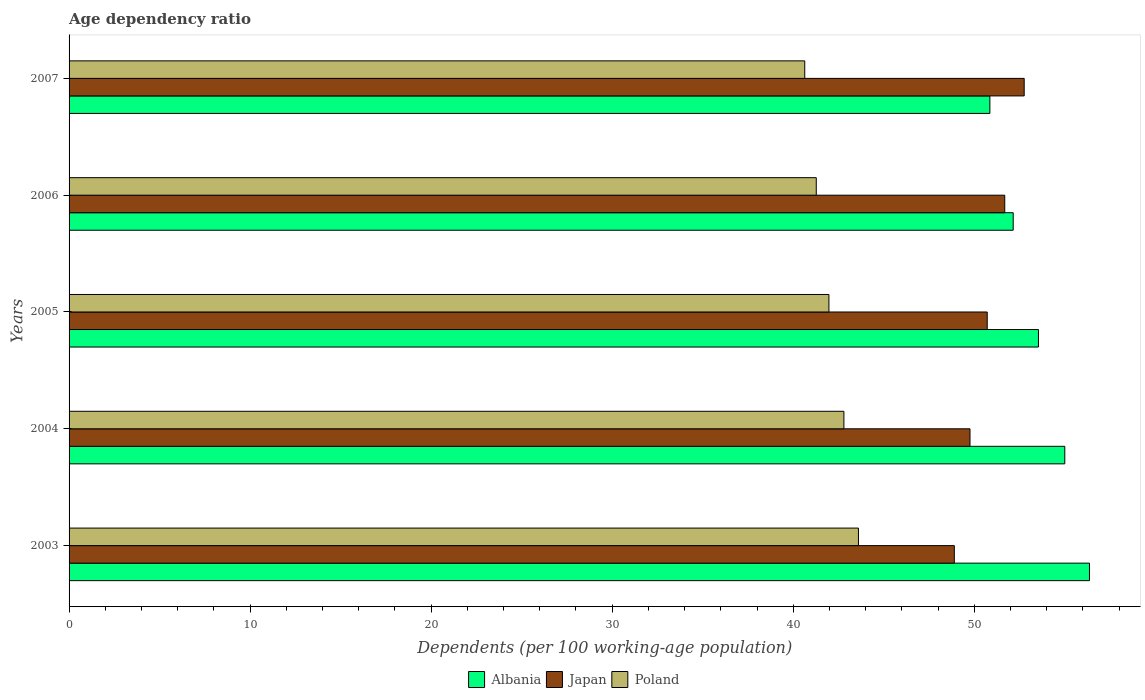How many bars are there on the 2nd tick from the top?
Make the answer very short. 3. How many bars are there on the 2nd tick from the bottom?
Offer a very short reply. 3. In how many cases, is the number of bars for a given year not equal to the number of legend labels?
Provide a succinct answer. 0. What is the age dependency ratio in in Poland in 2004?
Provide a succinct answer. 42.8. Across all years, what is the maximum age dependency ratio in in Albania?
Ensure brevity in your answer.  56.36. Across all years, what is the minimum age dependency ratio in in Japan?
Ensure brevity in your answer.  48.9. In which year was the age dependency ratio in in Japan maximum?
Keep it short and to the point. 2007. What is the total age dependency ratio in in Albania in the graph?
Provide a short and direct response. 267.93. What is the difference between the age dependency ratio in in Albania in 2003 and that in 2006?
Your answer should be very brief. 4.21. What is the difference between the age dependency ratio in in Japan in 2007 and the age dependency ratio in in Albania in 2003?
Keep it short and to the point. -3.61. What is the average age dependency ratio in in Albania per year?
Your response must be concise. 53.59. In the year 2006, what is the difference between the age dependency ratio in in Albania and age dependency ratio in in Poland?
Ensure brevity in your answer.  10.88. In how many years, is the age dependency ratio in in Albania greater than 40 %?
Provide a succinct answer. 5. What is the ratio of the age dependency ratio in in Poland in 2003 to that in 2004?
Your response must be concise. 1.02. Is the difference between the age dependency ratio in in Albania in 2003 and 2006 greater than the difference between the age dependency ratio in in Poland in 2003 and 2006?
Your answer should be compact. Yes. What is the difference between the highest and the second highest age dependency ratio in in Japan?
Offer a terse response. 1.07. What is the difference between the highest and the lowest age dependency ratio in in Poland?
Your answer should be compact. 2.97. In how many years, is the age dependency ratio in in Japan greater than the average age dependency ratio in in Japan taken over all years?
Provide a succinct answer. 2. Is the sum of the age dependency ratio in in Albania in 2006 and 2007 greater than the maximum age dependency ratio in in Japan across all years?
Offer a very short reply. Yes. What does the 3rd bar from the top in 2007 represents?
Give a very brief answer. Albania. What does the 3rd bar from the bottom in 2007 represents?
Offer a terse response. Poland. Is it the case that in every year, the sum of the age dependency ratio in in Albania and age dependency ratio in in Poland is greater than the age dependency ratio in in Japan?
Give a very brief answer. Yes. Are all the bars in the graph horizontal?
Your answer should be very brief. Yes. What is the difference between two consecutive major ticks on the X-axis?
Provide a short and direct response. 10. Does the graph contain any zero values?
Your answer should be compact. No. How many legend labels are there?
Provide a succinct answer. 3. How are the legend labels stacked?
Ensure brevity in your answer.  Horizontal. What is the title of the graph?
Your answer should be compact. Age dependency ratio. What is the label or title of the X-axis?
Keep it short and to the point. Dependents (per 100 working-age population). What is the Dependents (per 100 working-age population) of Albania in 2003?
Your answer should be very brief. 56.36. What is the Dependents (per 100 working-age population) in Japan in 2003?
Your response must be concise. 48.9. What is the Dependents (per 100 working-age population) of Poland in 2003?
Provide a succinct answer. 43.6. What is the Dependents (per 100 working-age population) of Albania in 2004?
Keep it short and to the point. 55. What is the Dependents (per 100 working-age population) of Japan in 2004?
Provide a short and direct response. 49.77. What is the Dependents (per 100 working-age population) in Poland in 2004?
Your response must be concise. 42.8. What is the Dependents (per 100 working-age population) in Albania in 2005?
Your answer should be very brief. 53.55. What is the Dependents (per 100 working-age population) in Japan in 2005?
Ensure brevity in your answer.  50.72. What is the Dependents (per 100 working-age population) of Poland in 2005?
Your response must be concise. 41.97. What is the Dependents (per 100 working-age population) in Albania in 2006?
Keep it short and to the point. 52.15. What is the Dependents (per 100 working-age population) of Japan in 2006?
Offer a very short reply. 51.68. What is the Dependents (per 100 working-age population) in Poland in 2006?
Give a very brief answer. 41.27. What is the Dependents (per 100 working-age population) of Albania in 2007?
Keep it short and to the point. 50.86. What is the Dependents (per 100 working-age population) of Japan in 2007?
Keep it short and to the point. 52.76. What is the Dependents (per 100 working-age population) in Poland in 2007?
Your response must be concise. 40.64. Across all years, what is the maximum Dependents (per 100 working-age population) of Albania?
Offer a very short reply. 56.36. Across all years, what is the maximum Dependents (per 100 working-age population) in Japan?
Provide a short and direct response. 52.76. Across all years, what is the maximum Dependents (per 100 working-age population) of Poland?
Keep it short and to the point. 43.6. Across all years, what is the minimum Dependents (per 100 working-age population) in Albania?
Make the answer very short. 50.86. Across all years, what is the minimum Dependents (per 100 working-age population) of Japan?
Make the answer very short. 48.9. Across all years, what is the minimum Dependents (per 100 working-age population) of Poland?
Offer a terse response. 40.64. What is the total Dependents (per 100 working-age population) of Albania in the graph?
Provide a short and direct response. 267.93. What is the total Dependents (per 100 working-age population) in Japan in the graph?
Provide a short and direct response. 253.82. What is the total Dependents (per 100 working-age population) of Poland in the graph?
Your answer should be compact. 210.29. What is the difference between the Dependents (per 100 working-age population) of Albania in 2003 and that in 2004?
Provide a succinct answer. 1.36. What is the difference between the Dependents (per 100 working-age population) of Japan in 2003 and that in 2004?
Keep it short and to the point. -0.87. What is the difference between the Dependents (per 100 working-age population) in Poland in 2003 and that in 2004?
Your answer should be compact. 0.8. What is the difference between the Dependents (per 100 working-age population) of Albania in 2003 and that in 2005?
Keep it short and to the point. 2.82. What is the difference between the Dependents (per 100 working-age population) in Japan in 2003 and that in 2005?
Your answer should be compact. -1.82. What is the difference between the Dependents (per 100 working-age population) of Poland in 2003 and that in 2005?
Make the answer very short. 1.63. What is the difference between the Dependents (per 100 working-age population) of Albania in 2003 and that in 2006?
Offer a very short reply. 4.21. What is the difference between the Dependents (per 100 working-age population) in Japan in 2003 and that in 2006?
Give a very brief answer. -2.79. What is the difference between the Dependents (per 100 working-age population) of Poland in 2003 and that in 2006?
Give a very brief answer. 2.33. What is the difference between the Dependents (per 100 working-age population) of Albania in 2003 and that in 2007?
Offer a terse response. 5.5. What is the difference between the Dependents (per 100 working-age population) of Japan in 2003 and that in 2007?
Your response must be concise. -3.86. What is the difference between the Dependents (per 100 working-age population) in Poland in 2003 and that in 2007?
Provide a short and direct response. 2.97. What is the difference between the Dependents (per 100 working-age population) in Albania in 2004 and that in 2005?
Your answer should be very brief. 1.45. What is the difference between the Dependents (per 100 working-age population) in Japan in 2004 and that in 2005?
Your response must be concise. -0.95. What is the difference between the Dependents (per 100 working-age population) in Poland in 2004 and that in 2005?
Offer a terse response. 0.83. What is the difference between the Dependents (per 100 working-age population) of Albania in 2004 and that in 2006?
Give a very brief answer. 2.85. What is the difference between the Dependents (per 100 working-age population) in Japan in 2004 and that in 2006?
Provide a succinct answer. -1.92. What is the difference between the Dependents (per 100 working-age population) of Poland in 2004 and that in 2006?
Keep it short and to the point. 1.53. What is the difference between the Dependents (per 100 working-age population) of Albania in 2004 and that in 2007?
Offer a terse response. 4.14. What is the difference between the Dependents (per 100 working-age population) of Japan in 2004 and that in 2007?
Give a very brief answer. -2.99. What is the difference between the Dependents (per 100 working-age population) of Poland in 2004 and that in 2007?
Your response must be concise. 2.16. What is the difference between the Dependents (per 100 working-age population) of Albania in 2005 and that in 2006?
Keep it short and to the point. 1.39. What is the difference between the Dependents (per 100 working-age population) in Japan in 2005 and that in 2006?
Your answer should be compact. -0.97. What is the difference between the Dependents (per 100 working-age population) in Poland in 2005 and that in 2006?
Make the answer very short. 0.7. What is the difference between the Dependents (per 100 working-age population) of Albania in 2005 and that in 2007?
Make the answer very short. 2.68. What is the difference between the Dependents (per 100 working-age population) in Japan in 2005 and that in 2007?
Offer a terse response. -2.04. What is the difference between the Dependents (per 100 working-age population) in Poland in 2005 and that in 2007?
Your answer should be very brief. 1.34. What is the difference between the Dependents (per 100 working-age population) of Albania in 2006 and that in 2007?
Your answer should be very brief. 1.29. What is the difference between the Dependents (per 100 working-age population) in Japan in 2006 and that in 2007?
Provide a short and direct response. -1.07. What is the difference between the Dependents (per 100 working-age population) in Poland in 2006 and that in 2007?
Make the answer very short. 0.64. What is the difference between the Dependents (per 100 working-age population) of Albania in 2003 and the Dependents (per 100 working-age population) of Japan in 2004?
Ensure brevity in your answer.  6.6. What is the difference between the Dependents (per 100 working-age population) in Albania in 2003 and the Dependents (per 100 working-age population) in Poland in 2004?
Provide a short and direct response. 13.56. What is the difference between the Dependents (per 100 working-age population) of Japan in 2003 and the Dependents (per 100 working-age population) of Poland in 2004?
Give a very brief answer. 6.1. What is the difference between the Dependents (per 100 working-age population) of Albania in 2003 and the Dependents (per 100 working-age population) of Japan in 2005?
Your response must be concise. 5.65. What is the difference between the Dependents (per 100 working-age population) in Albania in 2003 and the Dependents (per 100 working-age population) in Poland in 2005?
Your response must be concise. 14.39. What is the difference between the Dependents (per 100 working-age population) in Japan in 2003 and the Dependents (per 100 working-age population) in Poland in 2005?
Your answer should be very brief. 6.93. What is the difference between the Dependents (per 100 working-age population) in Albania in 2003 and the Dependents (per 100 working-age population) in Japan in 2006?
Your answer should be compact. 4.68. What is the difference between the Dependents (per 100 working-age population) of Albania in 2003 and the Dependents (per 100 working-age population) of Poland in 2006?
Provide a succinct answer. 15.09. What is the difference between the Dependents (per 100 working-age population) in Japan in 2003 and the Dependents (per 100 working-age population) in Poland in 2006?
Your answer should be compact. 7.63. What is the difference between the Dependents (per 100 working-age population) in Albania in 2003 and the Dependents (per 100 working-age population) in Japan in 2007?
Your answer should be compact. 3.61. What is the difference between the Dependents (per 100 working-age population) in Albania in 2003 and the Dependents (per 100 working-age population) in Poland in 2007?
Ensure brevity in your answer.  15.73. What is the difference between the Dependents (per 100 working-age population) in Japan in 2003 and the Dependents (per 100 working-age population) in Poland in 2007?
Your response must be concise. 8.26. What is the difference between the Dependents (per 100 working-age population) in Albania in 2004 and the Dependents (per 100 working-age population) in Japan in 2005?
Ensure brevity in your answer.  4.29. What is the difference between the Dependents (per 100 working-age population) of Albania in 2004 and the Dependents (per 100 working-age population) of Poland in 2005?
Offer a very short reply. 13.03. What is the difference between the Dependents (per 100 working-age population) of Japan in 2004 and the Dependents (per 100 working-age population) of Poland in 2005?
Keep it short and to the point. 7.79. What is the difference between the Dependents (per 100 working-age population) in Albania in 2004 and the Dependents (per 100 working-age population) in Japan in 2006?
Ensure brevity in your answer.  3.32. What is the difference between the Dependents (per 100 working-age population) in Albania in 2004 and the Dependents (per 100 working-age population) in Poland in 2006?
Your answer should be compact. 13.73. What is the difference between the Dependents (per 100 working-age population) of Japan in 2004 and the Dependents (per 100 working-age population) of Poland in 2006?
Offer a terse response. 8.49. What is the difference between the Dependents (per 100 working-age population) in Albania in 2004 and the Dependents (per 100 working-age population) in Japan in 2007?
Give a very brief answer. 2.24. What is the difference between the Dependents (per 100 working-age population) in Albania in 2004 and the Dependents (per 100 working-age population) in Poland in 2007?
Your answer should be very brief. 14.36. What is the difference between the Dependents (per 100 working-age population) in Japan in 2004 and the Dependents (per 100 working-age population) in Poland in 2007?
Provide a succinct answer. 9.13. What is the difference between the Dependents (per 100 working-age population) in Albania in 2005 and the Dependents (per 100 working-age population) in Japan in 2006?
Your response must be concise. 1.86. What is the difference between the Dependents (per 100 working-age population) of Albania in 2005 and the Dependents (per 100 working-age population) of Poland in 2006?
Your response must be concise. 12.27. What is the difference between the Dependents (per 100 working-age population) in Japan in 2005 and the Dependents (per 100 working-age population) in Poland in 2006?
Your answer should be compact. 9.44. What is the difference between the Dependents (per 100 working-age population) in Albania in 2005 and the Dependents (per 100 working-age population) in Japan in 2007?
Your response must be concise. 0.79. What is the difference between the Dependents (per 100 working-age population) in Albania in 2005 and the Dependents (per 100 working-age population) in Poland in 2007?
Give a very brief answer. 12.91. What is the difference between the Dependents (per 100 working-age population) in Japan in 2005 and the Dependents (per 100 working-age population) in Poland in 2007?
Keep it short and to the point. 10.08. What is the difference between the Dependents (per 100 working-age population) of Albania in 2006 and the Dependents (per 100 working-age population) of Japan in 2007?
Provide a short and direct response. -0.61. What is the difference between the Dependents (per 100 working-age population) in Albania in 2006 and the Dependents (per 100 working-age population) in Poland in 2007?
Your answer should be compact. 11.51. What is the difference between the Dependents (per 100 working-age population) of Japan in 2006 and the Dependents (per 100 working-age population) of Poland in 2007?
Give a very brief answer. 11.05. What is the average Dependents (per 100 working-age population) in Albania per year?
Offer a terse response. 53.59. What is the average Dependents (per 100 working-age population) of Japan per year?
Give a very brief answer. 50.77. What is the average Dependents (per 100 working-age population) of Poland per year?
Provide a short and direct response. 42.06. In the year 2003, what is the difference between the Dependents (per 100 working-age population) in Albania and Dependents (per 100 working-age population) in Japan?
Your response must be concise. 7.47. In the year 2003, what is the difference between the Dependents (per 100 working-age population) in Albania and Dependents (per 100 working-age population) in Poland?
Keep it short and to the point. 12.76. In the year 2003, what is the difference between the Dependents (per 100 working-age population) in Japan and Dependents (per 100 working-age population) in Poland?
Your answer should be very brief. 5.3. In the year 2004, what is the difference between the Dependents (per 100 working-age population) of Albania and Dependents (per 100 working-age population) of Japan?
Provide a succinct answer. 5.24. In the year 2004, what is the difference between the Dependents (per 100 working-age population) in Albania and Dependents (per 100 working-age population) in Poland?
Provide a short and direct response. 12.2. In the year 2004, what is the difference between the Dependents (per 100 working-age population) in Japan and Dependents (per 100 working-age population) in Poland?
Offer a terse response. 6.96. In the year 2005, what is the difference between the Dependents (per 100 working-age population) of Albania and Dependents (per 100 working-age population) of Japan?
Your response must be concise. 2.83. In the year 2005, what is the difference between the Dependents (per 100 working-age population) of Albania and Dependents (per 100 working-age population) of Poland?
Offer a very short reply. 11.57. In the year 2005, what is the difference between the Dependents (per 100 working-age population) of Japan and Dependents (per 100 working-age population) of Poland?
Offer a terse response. 8.74. In the year 2006, what is the difference between the Dependents (per 100 working-age population) in Albania and Dependents (per 100 working-age population) in Japan?
Give a very brief answer. 0.47. In the year 2006, what is the difference between the Dependents (per 100 working-age population) of Albania and Dependents (per 100 working-age population) of Poland?
Your answer should be compact. 10.88. In the year 2006, what is the difference between the Dependents (per 100 working-age population) of Japan and Dependents (per 100 working-age population) of Poland?
Provide a succinct answer. 10.41. In the year 2007, what is the difference between the Dependents (per 100 working-age population) of Albania and Dependents (per 100 working-age population) of Japan?
Offer a terse response. -1.9. In the year 2007, what is the difference between the Dependents (per 100 working-age population) in Albania and Dependents (per 100 working-age population) in Poland?
Provide a succinct answer. 10.23. In the year 2007, what is the difference between the Dependents (per 100 working-age population) of Japan and Dependents (per 100 working-age population) of Poland?
Keep it short and to the point. 12.12. What is the ratio of the Dependents (per 100 working-age population) in Albania in 2003 to that in 2004?
Your answer should be very brief. 1.02. What is the ratio of the Dependents (per 100 working-age population) of Japan in 2003 to that in 2004?
Provide a succinct answer. 0.98. What is the ratio of the Dependents (per 100 working-age population) in Poland in 2003 to that in 2004?
Your response must be concise. 1.02. What is the ratio of the Dependents (per 100 working-age population) in Albania in 2003 to that in 2005?
Ensure brevity in your answer.  1.05. What is the ratio of the Dependents (per 100 working-age population) of Japan in 2003 to that in 2005?
Offer a terse response. 0.96. What is the ratio of the Dependents (per 100 working-age population) in Poland in 2003 to that in 2005?
Provide a succinct answer. 1.04. What is the ratio of the Dependents (per 100 working-age population) in Albania in 2003 to that in 2006?
Keep it short and to the point. 1.08. What is the ratio of the Dependents (per 100 working-age population) of Japan in 2003 to that in 2006?
Your response must be concise. 0.95. What is the ratio of the Dependents (per 100 working-age population) in Poland in 2003 to that in 2006?
Keep it short and to the point. 1.06. What is the ratio of the Dependents (per 100 working-age population) in Albania in 2003 to that in 2007?
Your answer should be very brief. 1.11. What is the ratio of the Dependents (per 100 working-age population) of Japan in 2003 to that in 2007?
Your answer should be compact. 0.93. What is the ratio of the Dependents (per 100 working-age population) in Poland in 2003 to that in 2007?
Provide a short and direct response. 1.07. What is the ratio of the Dependents (per 100 working-age population) in Albania in 2004 to that in 2005?
Your answer should be very brief. 1.03. What is the ratio of the Dependents (per 100 working-age population) of Japan in 2004 to that in 2005?
Ensure brevity in your answer.  0.98. What is the ratio of the Dependents (per 100 working-age population) of Poland in 2004 to that in 2005?
Your response must be concise. 1.02. What is the ratio of the Dependents (per 100 working-age population) in Albania in 2004 to that in 2006?
Your answer should be compact. 1.05. What is the ratio of the Dependents (per 100 working-age population) of Japan in 2004 to that in 2006?
Keep it short and to the point. 0.96. What is the ratio of the Dependents (per 100 working-age population) of Albania in 2004 to that in 2007?
Offer a very short reply. 1.08. What is the ratio of the Dependents (per 100 working-age population) of Japan in 2004 to that in 2007?
Offer a very short reply. 0.94. What is the ratio of the Dependents (per 100 working-age population) in Poland in 2004 to that in 2007?
Your response must be concise. 1.05. What is the ratio of the Dependents (per 100 working-age population) in Albania in 2005 to that in 2006?
Ensure brevity in your answer.  1.03. What is the ratio of the Dependents (per 100 working-age population) of Japan in 2005 to that in 2006?
Ensure brevity in your answer.  0.98. What is the ratio of the Dependents (per 100 working-age population) in Poland in 2005 to that in 2006?
Offer a terse response. 1.02. What is the ratio of the Dependents (per 100 working-age population) in Albania in 2005 to that in 2007?
Provide a short and direct response. 1.05. What is the ratio of the Dependents (per 100 working-age population) of Japan in 2005 to that in 2007?
Your answer should be very brief. 0.96. What is the ratio of the Dependents (per 100 working-age population) in Poland in 2005 to that in 2007?
Provide a succinct answer. 1.03. What is the ratio of the Dependents (per 100 working-age population) in Albania in 2006 to that in 2007?
Offer a very short reply. 1.03. What is the ratio of the Dependents (per 100 working-age population) in Japan in 2006 to that in 2007?
Provide a short and direct response. 0.98. What is the ratio of the Dependents (per 100 working-age population) in Poland in 2006 to that in 2007?
Ensure brevity in your answer.  1.02. What is the difference between the highest and the second highest Dependents (per 100 working-age population) in Albania?
Offer a terse response. 1.36. What is the difference between the highest and the second highest Dependents (per 100 working-age population) in Japan?
Your answer should be very brief. 1.07. What is the difference between the highest and the second highest Dependents (per 100 working-age population) of Poland?
Keep it short and to the point. 0.8. What is the difference between the highest and the lowest Dependents (per 100 working-age population) in Albania?
Provide a succinct answer. 5.5. What is the difference between the highest and the lowest Dependents (per 100 working-age population) of Japan?
Your answer should be very brief. 3.86. What is the difference between the highest and the lowest Dependents (per 100 working-age population) of Poland?
Ensure brevity in your answer.  2.97. 